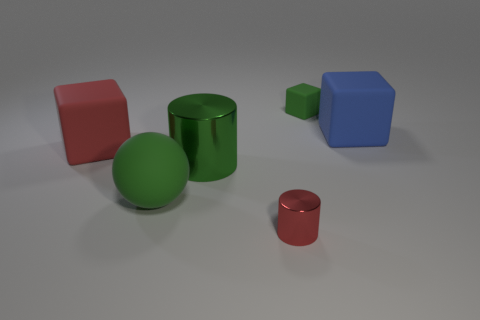Add 1 big green shiny cylinders. How many objects exist? 7 Subtract all cylinders. How many objects are left? 4 Add 4 tiny rubber objects. How many tiny rubber objects are left? 5 Add 6 large red objects. How many large red objects exist? 7 Subtract 0 purple cubes. How many objects are left? 6 Subtract all large red matte things. Subtract all small green objects. How many objects are left? 4 